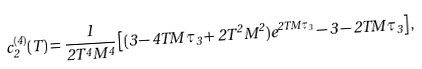Convert formula to latex. <formula><loc_0><loc_0><loc_500><loc_500>c ^ { ( 4 ) } _ { 2 } ( T ) = \frac { 1 } { 2 T ^ { 4 } M ^ { 4 } } \left [ ( 3 - 4 T M \tau _ { 3 } + 2 T ^ { 2 } M ^ { 2 } ) e ^ { 2 T M \tau _ { 3 } } - 3 - 2 T M \tau _ { 3 } \right ] ,</formula> 